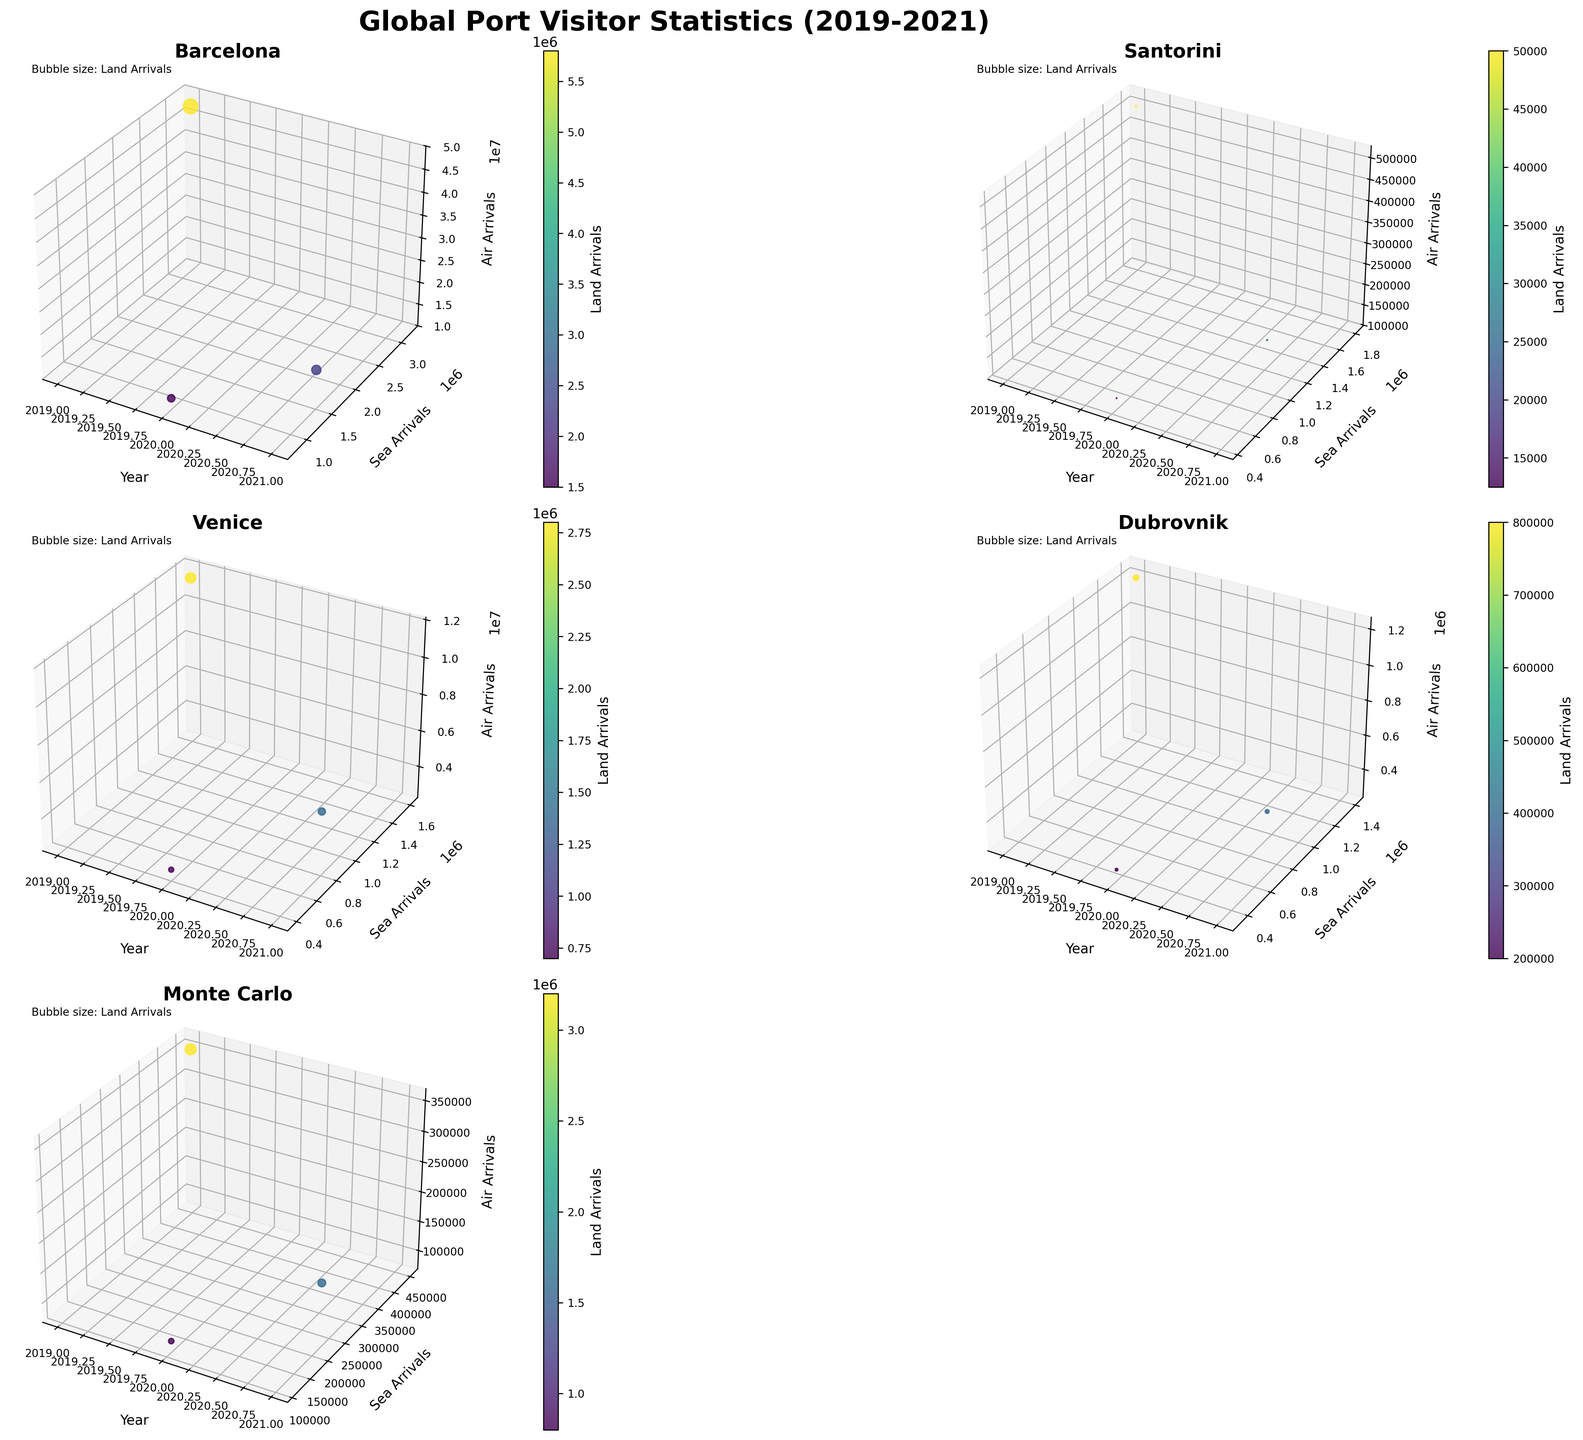Which destination has the highest number of sea arrivals in 2019? Look at the 3D subplot for each destination and identify the highest sea arrivals in 2019. Barcelona exceeds others with 3,200,000 sea arrivals.
Answer: Barcelona Which destination has the smallest bubble in 2020, indicating the smallest land arrivals? Locate the bubbles corresponding to 2020 in each subplot and compare their sizes. The smallest bubble, indicating the smallest land arrivals, is found in Santorini.
Answer: Santorini What are the air arrivals in Venice in 2021? Check the subplot for Venice and find the point corresponding to the year 2021. The 'Air Arrivals' axis shows approximately 5,750,000.
Answer: 5,750,000 How did Santorini's sea arrivals change from 2019 to 2021? Observe the subplot titled 'Santorini' and compare the sea arrivals in 2019, 2020, and 2021. The sea arrivals decreased from 1,800,000 in 2019 to 450,000 in 2020, then increased to 900,000 in 2021.
Answer: They decreased in 2020 and increased in 2021 Which destination had the most significant drop in air arrivals from 2019 to 2020? Compare the difference in air arrivals in the subplots for all destinations between 2019 and 2020. Barcelona had the highest drop from 47,500,000 to 12,500,000.
Answer: Barcelona Compare the sea arrivals of Dubrovnik and Monte Carlo in 2021. Which one had more visitors? Observe the subplots for Dubrovnik and Monte Carlo for the year 2021 and compare their sea arrivals. Dubrovnik had 700,000 and Monte Carlo had 225,000.
Answer: Dubrovnik What is the trend of land arrivals in Barcelona from 2019 to 2021? Look at the subplot for Barcelona and examine the land arrivals each year. Land arrivals dropped from 5,800,000 in 2019 to 1,500,000 in 2020 and then increased to 2,300,000 in 2021.
Answer: Decreasing then increasing Identify the year with the highest air arrivals for Monte Carlo. Examine the subplot for Monte Carlo and identify the year with the highest point on the 'Air Arrivals' axis. The highest value is 350,000 in 2019.
Answer: 2019 